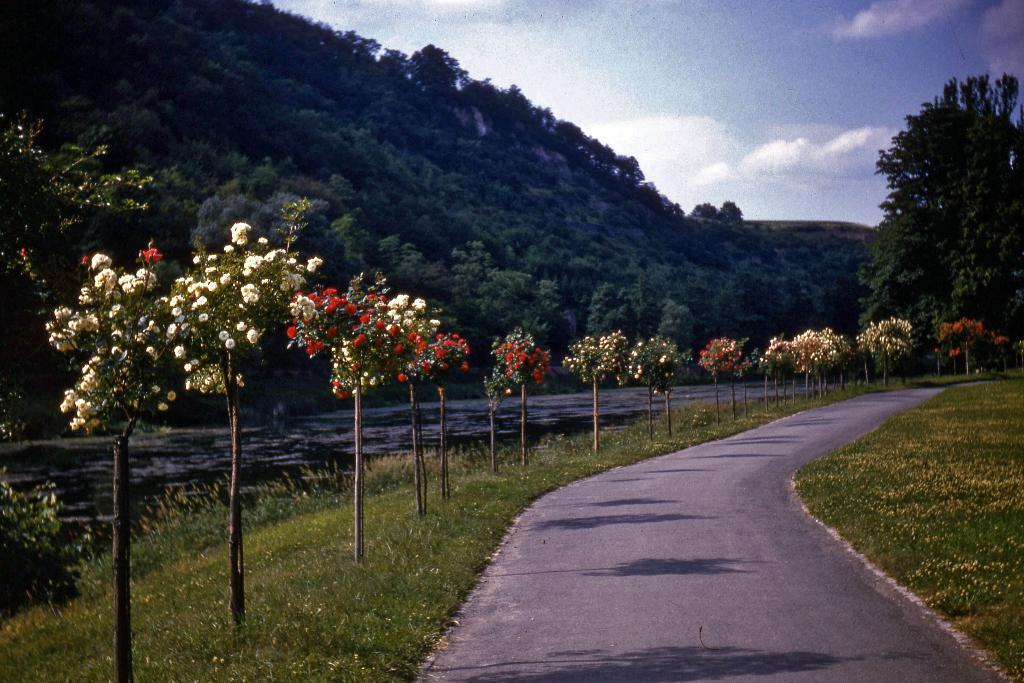What is located at the bottom side of the image? There is a way at the bottom side of the image. What type of vegetation can be seen in the image? There are flower plants and trees in the image. What part of the natural environment is visible in the image? The sky is visible in the image. What is the purpose of the oven in the image? There is no oven present in the image. 